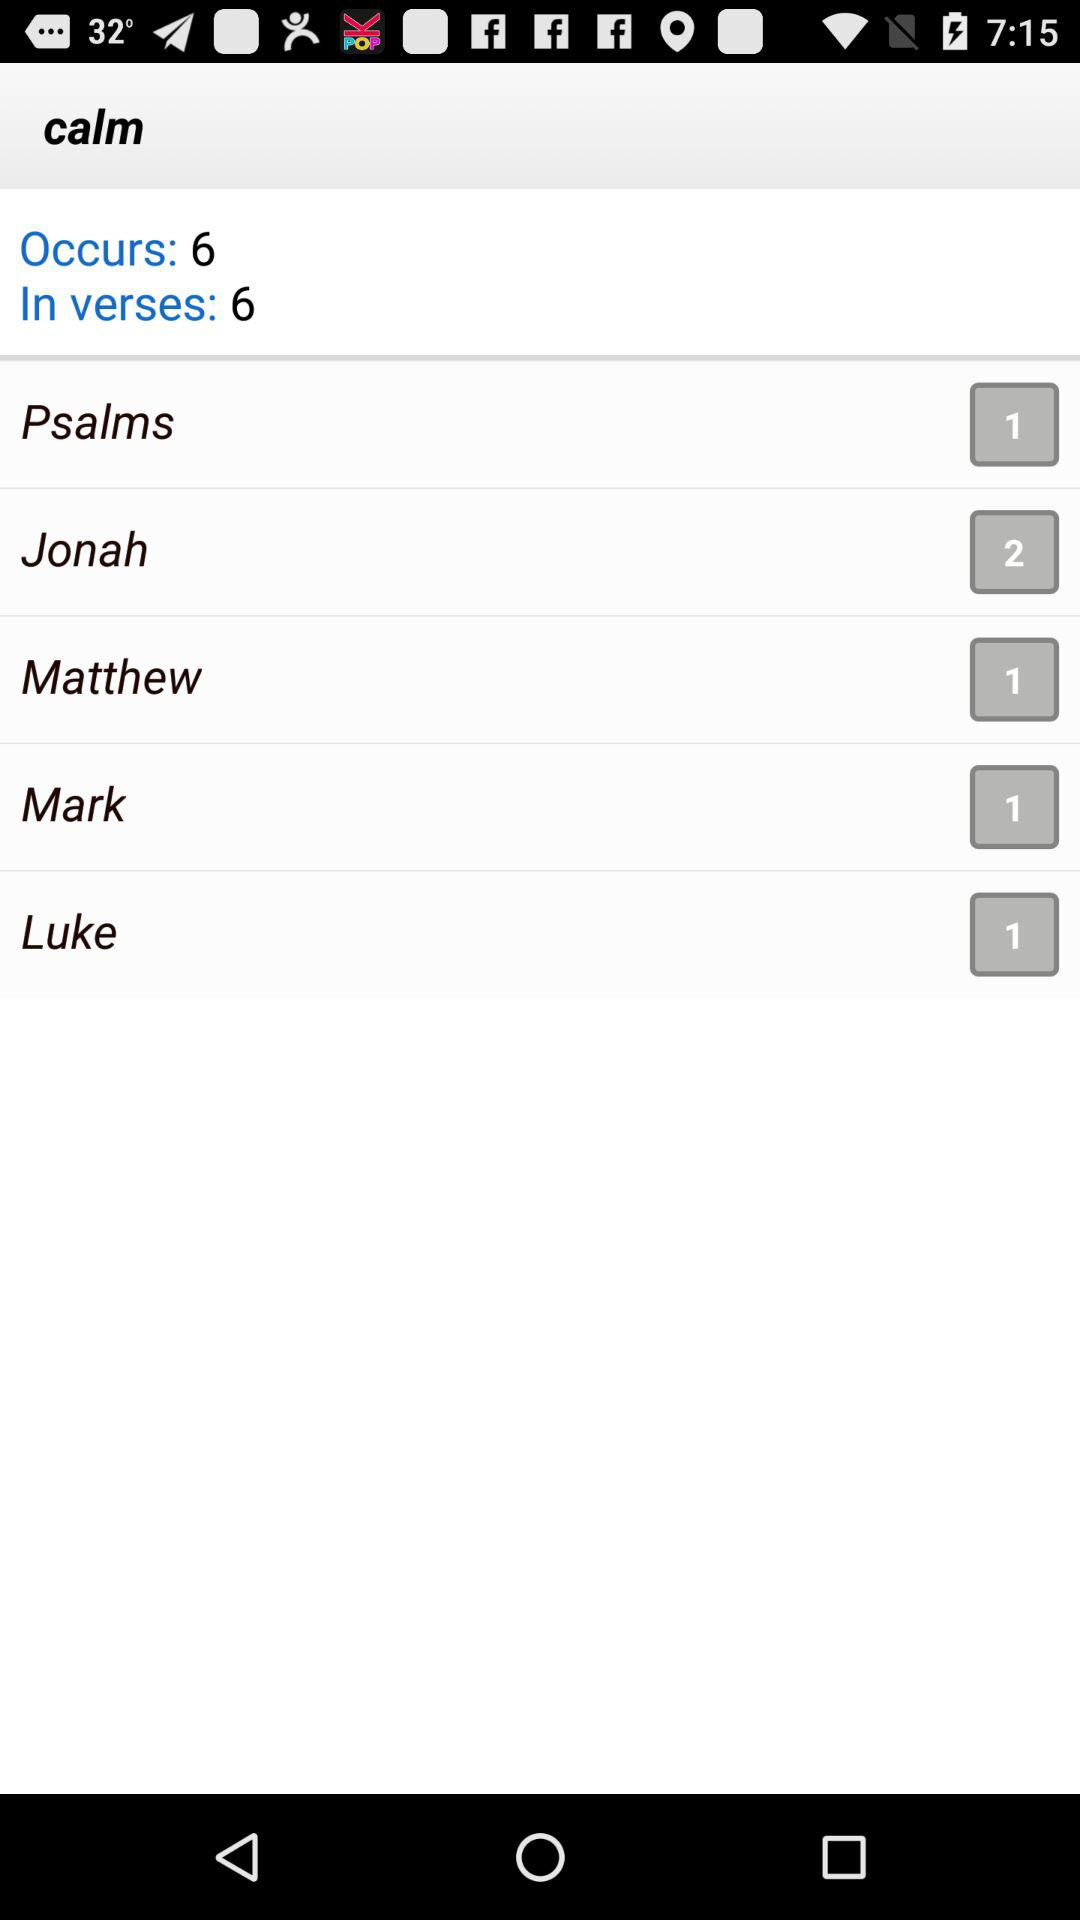What is the name of the application? The name of the application is "calm". 